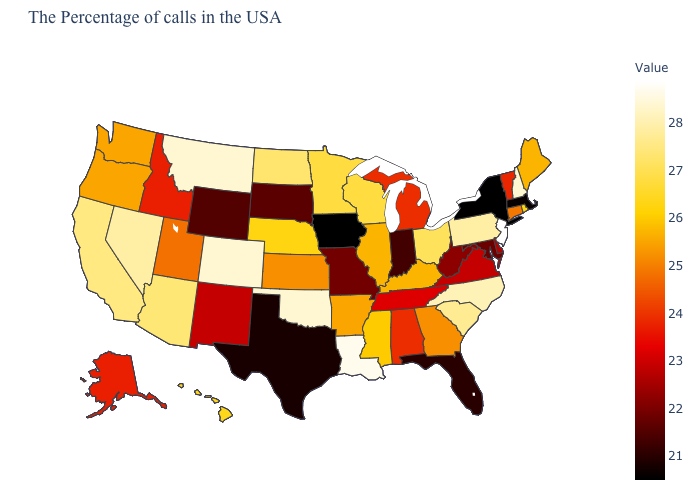Does the map have missing data?
Write a very short answer. No. Is the legend a continuous bar?
Short answer required. Yes. Is the legend a continuous bar?
Be succinct. Yes. Which states have the lowest value in the USA?
Short answer required. New York, Iowa. Does the map have missing data?
Give a very brief answer. No. 